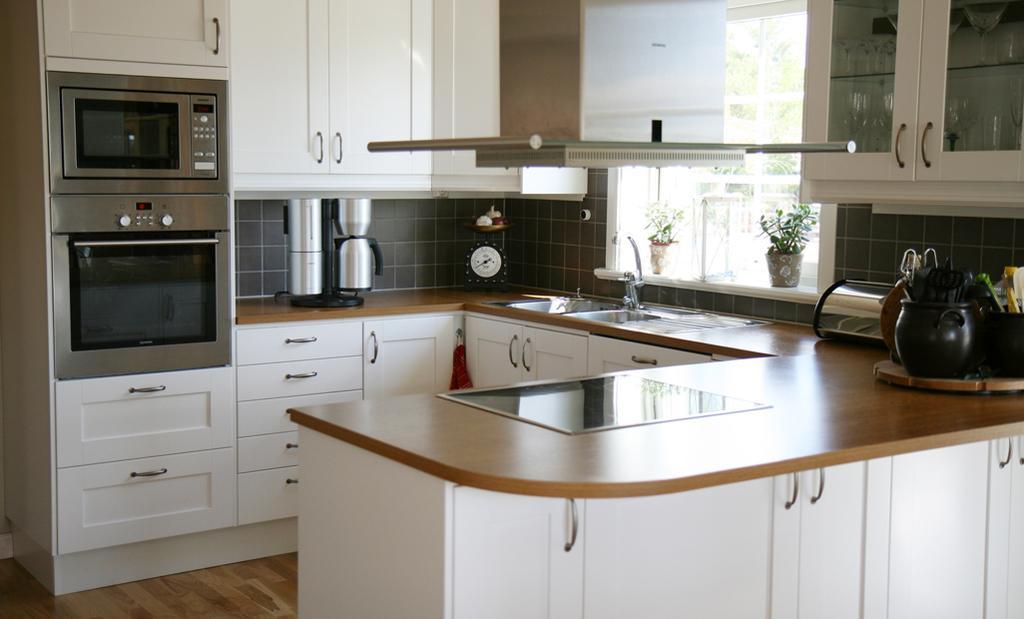Please provide a concise description of this image. In this image I can see counter tops, a sink, a water tap, few plants, few cupboards, few drawers, a microwave, an oven and I can also see ew other stuffs on these counter tops. Here I can see number of glasses. 